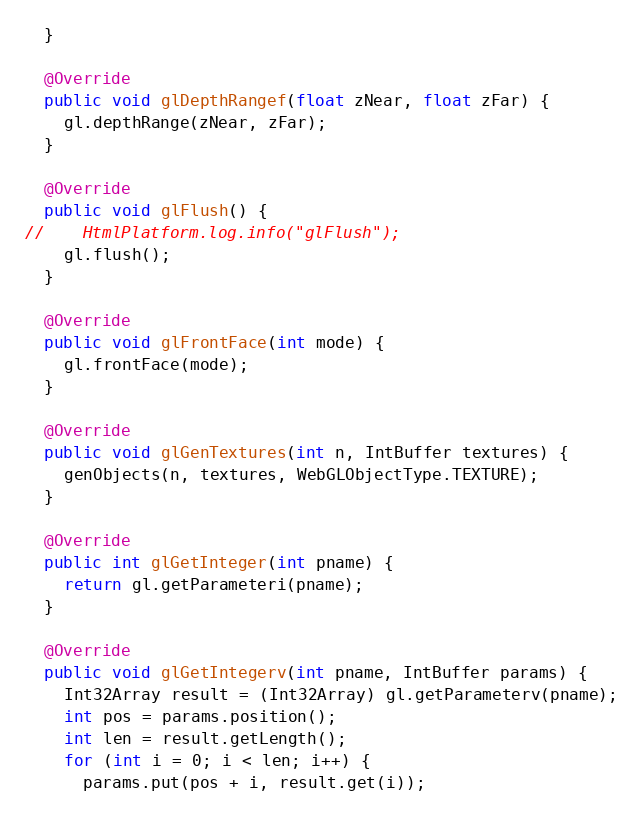Convert code to text. <code><loc_0><loc_0><loc_500><loc_500><_Java_>  }

  @Override
  public void glDepthRangef(float zNear, float zFar) {
    gl.depthRange(zNear, zFar);
  }

  @Override
  public void glFlush() {
//    HtmlPlatform.log.info("glFlush");
    gl.flush();
  }

  @Override
  public void glFrontFace(int mode) {
    gl.frontFace(mode);
  }

  @Override
  public void glGenTextures(int n, IntBuffer textures) {
    genObjects(n, textures, WebGLObjectType.TEXTURE);
  }

  @Override
  public int glGetInteger(int pname) {
    return gl.getParameteri(pname);
  }

  @Override
  public void glGetIntegerv(int pname, IntBuffer params) {
    Int32Array result = (Int32Array) gl.getParameterv(pname);
    int pos = params.position();
    int len = result.getLength();
    for (int i = 0; i < len; i++) {
      params.put(pos + i, result.get(i));</code> 